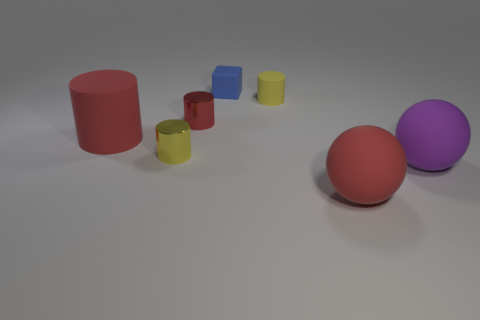Subtract all small cylinders. How many cylinders are left? 1 Subtract all cylinders. How many objects are left? 3 Add 2 large shiny blocks. How many objects exist? 9 Add 7 small cyan cubes. How many small cyan cubes exist? 7 Subtract all purple balls. How many balls are left? 1 Subtract 0 blue spheres. How many objects are left? 7 Subtract 1 cylinders. How many cylinders are left? 3 Subtract all green spheres. Subtract all blue cylinders. How many spheres are left? 2 Subtract all cyan cubes. How many purple balls are left? 1 Subtract all big objects. Subtract all large red cylinders. How many objects are left? 3 